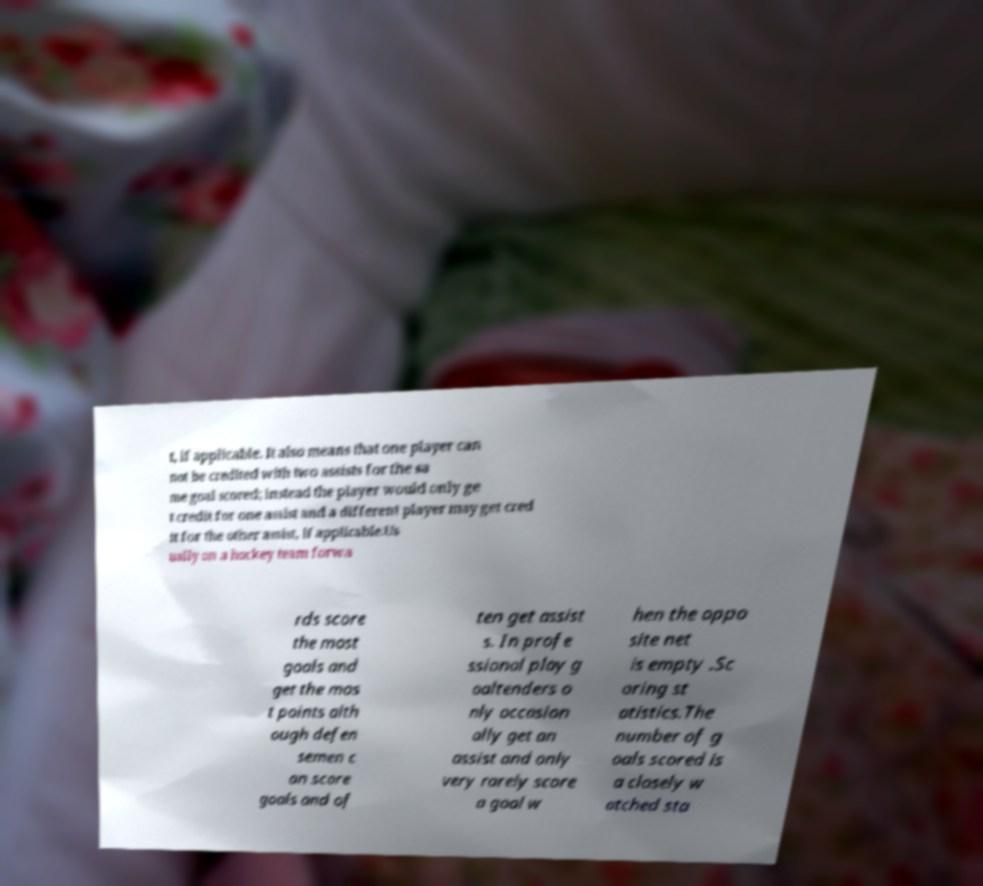Could you extract and type out the text from this image? t, if applicable. It also means that one player can not be credited with two assists for the sa me goal scored; instead the player would only ge t credit for one assist and a different player may get cred it for the other assist, if applicable.Us ually on a hockey team forwa rds score the most goals and get the mos t points alth ough defen semen c an score goals and of ten get assist s. In profe ssional play g oaltenders o nly occasion ally get an assist and only very rarely score a goal w hen the oppo site net is empty .Sc oring st atistics.The number of g oals scored is a closely w atched sta 